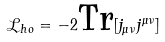<formula> <loc_0><loc_0><loc_500><loc_500>\mathcal { L } _ { h o } = - 2 \text {Tr} [ j _ { \mu \nu } j ^ { \mu \nu } ]</formula> 